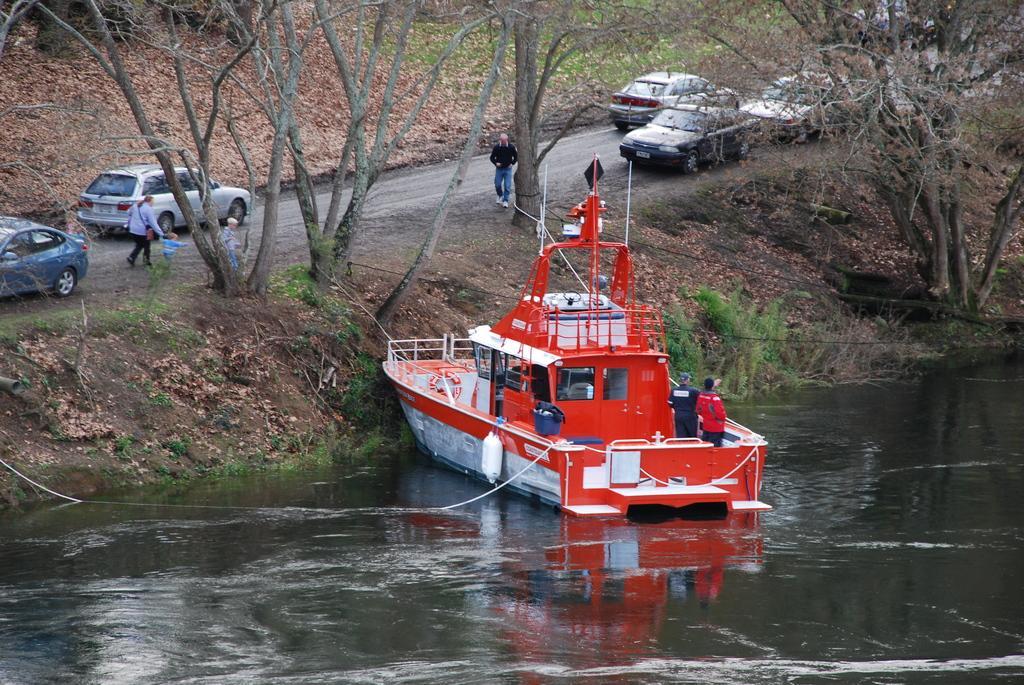In one or two sentences, can you explain what this image depicts? This picture is taken beside the river. On the river, there is a road which is in red and white in color. On the boat, there are two people. Beside the river, there is a road. On the road, there are vehicles. On either side of the road, there are trees and plants. Towards the left, there is a woman carrying a bag and holding a kid. Before them, there is another kid. In the center, there is a man wearing a black shirt and a blue jeans. 